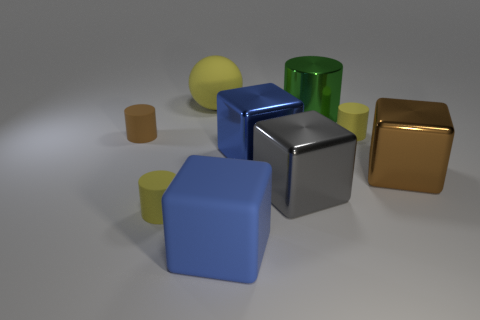What is the material of the tiny brown thing that is the same shape as the green object?
Provide a short and direct response. Rubber. Is the number of brown objects greater than the number of small things?
Your answer should be very brief. No. What size is the object that is to the right of the large cylinder and in front of the blue shiny cube?
Your response must be concise. Large. What shape is the small brown object?
Offer a terse response. Cylinder. How many blue matte things have the same shape as the green thing?
Offer a very short reply. 0. Is the number of big blue things behind the big brown metal object less than the number of matte things that are to the left of the sphere?
Offer a very short reply. Yes. What number of matte cylinders are to the left of the big blue thing that is in front of the brown cube?
Keep it short and to the point. 2. Is there a cyan cube?
Keep it short and to the point. No. Are there any big blue things that have the same material as the gray cube?
Offer a terse response. Yes. Is the number of blue shiny things in front of the ball greater than the number of gray metallic things that are behind the brown block?
Give a very brief answer. Yes. 